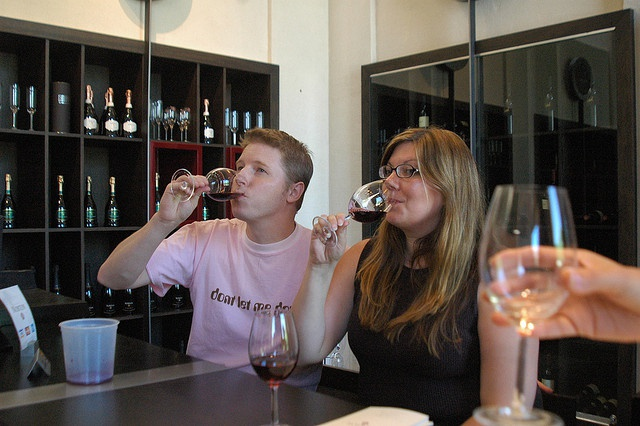Describe the objects in this image and their specific colors. I can see people in tan, black, gray, and maroon tones, people in tan, darkgray, and gray tones, dining table in tan, black, and gray tones, wine glass in tan, gray, black, and darkgray tones, and bottle in tan, black, maroon, and gray tones in this image. 